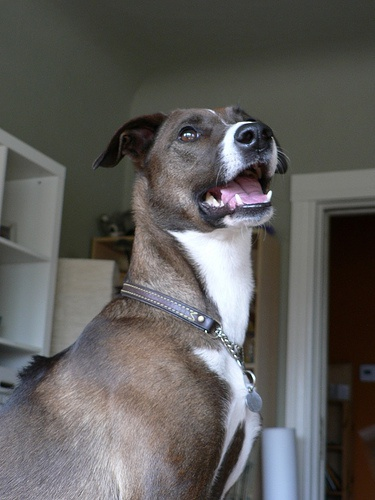Describe the objects in this image and their specific colors. I can see a dog in gray, darkgray, black, and lavender tones in this image. 